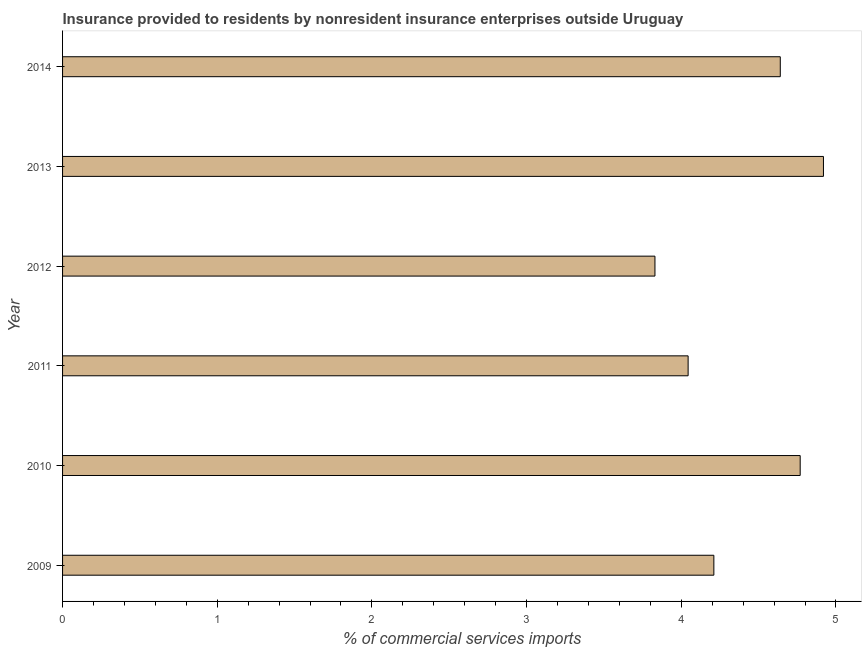Does the graph contain any zero values?
Provide a short and direct response. No. What is the title of the graph?
Make the answer very short. Insurance provided to residents by nonresident insurance enterprises outside Uruguay. What is the label or title of the X-axis?
Ensure brevity in your answer.  % of commercial services imports. What is the label or title of the Y-axis?
Offer a terse response. Year. What is the insurance provided by non-residents in 2011?
Make the answer very short. 4.04. Across all years, what is the maximum insurance provided by non-residents?
Keep it short and to the point. 4.92. Across all years, what is the minimum insurance provided by non-residents?
Provide a short and direct response. 3.83. What is the sum of the insurance provided by non-residents?
Your answer should be compact. 26.41. What is the difference between the insurance provided by non-residents in 2009 and 2010?
Keep it short and to the point. -0.56. What is the average insurance provided by non-residents per year?
Make the answer very short. 4.4. What is the median insurance provided by non-residents?
Keep it short and to the point. 4.43. What is the ratio of the insurance provided by non-residents in 2010 to that in 2012?
Ensure brevity in your answer.  1.25. Is the difference between the insurance provided by non-residents in 2012 and 2014 greater than the difference between any two years?
Offer a terse response. No. What is the difference between the highest and the lowest insurance provided by non-residents?
Give a very brief answer. 1.09. How many bars are there?
Provide a succinct answer. 6. Are all the bars in the graph horizontal?
Your answer should be very brief. Yes. What is the difference between two consecutive major ticks on the X-axis?
Ensure brevity in your answer.  1. What is the % of commercial services imports in 2009?
Your answer should be very brief. 4.21. What is the % of commercial services imports of 2010?
Ensure brevity in your answer.  4.77. What is the % of commercial services imports of 2011?
Make the answer very short. 4.04. What is the % of commercial services imports of 2012?
Give a very brief answer. 3.83. What is the % of commercial services imports of 2013?
Keep it short and to the point. 4.92. What is the % of commercial services imports of 2014?
Your response must be concise. 4.64. What is the difference between the % of commercial services imports in 2009 and 2010?
Offer a very short reply. -0.56. What is the difference between the % of commercial services imports in 2009 and 2011?
Provide a succinct answer. 0.17. What is the difference between the % of commercial services imports in 2009 and 2012?
Provide a succinct answer. 0.38. What is the difference between the % of commercial services imports in 2009 and 2013?
Offer a very short reply. -0.71. What is the difference between the % of commercial services imports in 2009 and 2014?
Make the answer very short. -0.43. What is the difference between the % of commercial services imports in 2010 and 2011?
Ensure brevity in your answer.  0.72. What is the difference between the % of commercial services imports in 2010 and 2012?
Make the answer very short. 0.94. What is the difference between the % of commercial services imports in 2010 and 2013?
Offer a terse response. -0.15. What is the difference between the % of commercial services imports in 2010 and 2014?
Make the answer very short. 0.13. What is the difference between the % of commercial services imports in 2011 and 2012?
Your response must be concise. 0.21. What is the difference between the % of commercial services imports in 2011 and 2013?
Make the answer very short. -0.87. What is the difference between the % of commercial services imports in 2011 and 2014?
Offer a terse response. -0.6. What is the difference between the % of commercial services imports in 2012 and 2013?
Ensure brevity in your answer.  -1.09. What is the difference between the % of commercial services imports in 2012 and 2014?
Offer a very short reply. -0.81. What is the difference between the % of commercial services imports in 2013 and 2014?
Keep it short and to the point. 0.28. What is the ratio of the % of commercial services imports in 2009 to that in 2010?
Offer a very short reply. 0.88. What is the ratio of the % of commercial services imports in 2009 to that in 2011?
Give a very brief answer. 1.04. What is the ratio of the % of commercial services imports in 2009 to that in 2012?
Make the answer very short. 1.1. What is the ratio of the % of commercial services imports in 2009 to that in 2013?
Provide a short and direct response. 0.86. What is the ratio of the % of commercial services imports in 2009 to that in 2014?
Keep it short and to the point. 0.91. What is the ratio of the % of commercial services imports in 2010 to that in 2011?
Make the answer very short. 1.18. What is the ratio of the % of commercial services imports in 2010 to that in 2012?
Offer a terse response. 1.25. What is the ratio of the % of commercial services imports in 2010 to that in 2013?
Make the answer very short. 0.97. What is the ratio of the % of commercial services imports in 2010 to that in 2014?
Ensure brevity in your answer.  1.03. What is the ratio of the % of commercial services imports in 2011 to that in 2012?
Make the answer very short. 1.06. What is the ratio of the % of commercial services imports in 2011 to that in 2013?
Offer a terse response. 0.82. What is the ratio of the % of commercial services imports in 2011 to that in 2014?
Provide a succinct answer. 0.87. What is the ratio of the % of commercial services imports in 2012 to that in 2013?
Give a very brief answer. 0.78. What is the ratio of the % of commercial services imports in 2012 to that in 2014?
Offer a very short reply. 0.82. What is the ratio of the % of commercial services imports in 2013 to that in 2014?
Offer a very short reply. 1.06. 